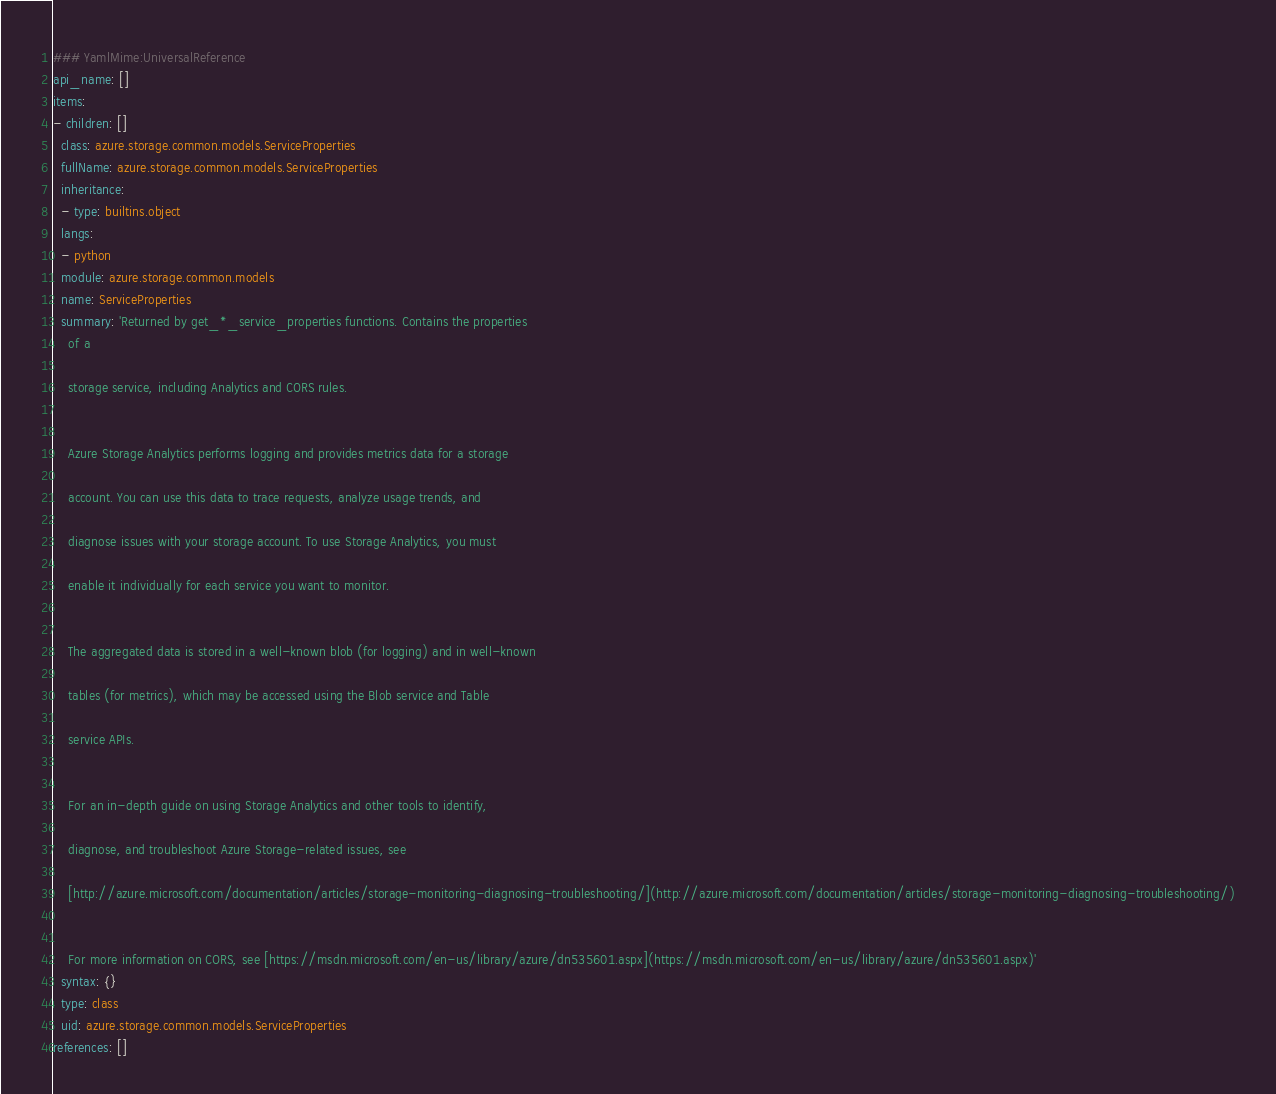<code> <loc_0><loc_0><loc_500><loc_500><_YAML_>### YamlMime:UniversalReference
api_name: []
items:
- children: []
  class: azure.storage.common.models.ServiceProperties
  fullName: azure.storage.common.models.ServiceProperties
  inheritance:
  - type: builtins.object
  langs:
  - python
  module: azure.storage.common.models
  name: ServiceProperties
  summary: 'Returned by get_*_service_properties functions. Contains the properties
    of a

    storage service, including Analytics and CORS rules.


    Azure Storage Analytics performs logging and provides metrics data for a storage

    account. You can use this data to trace requests, analyze usage trends, and

    diagnose issues with your storage account. To use Storage Analytics, you must

    enable it individually for each service you want to monitor.


    The aggregated data is stored in a well-known blob (for logging) and in well-known

    tables (for metrics), which may be accessed using the Blob service and Table

    service APIs.


    For an in-depth guide on using Storage Analytics and other tools to identify,

    diagnose, and troubleshoot Azure Storage-related issues, see

    [http://azure.microsoft.com/documentation/articles/storage-monitoring-diagnosing-troubleshooting/](http://azure.microsoft.com/documentation/articles/storage-monitoring-diagnosing-troubleshooting/)


    For more information on CORS, see [https://msdn.microsoft.com/en-us/library/azure/dn535601.aspx](https://msdn.microsoft.com/en-us/library/azure/dn535601.aspx)'
  syntax: {}
  type: class
  uid: azure.storage.common.models.ServiceProperties
references: []
</code> 